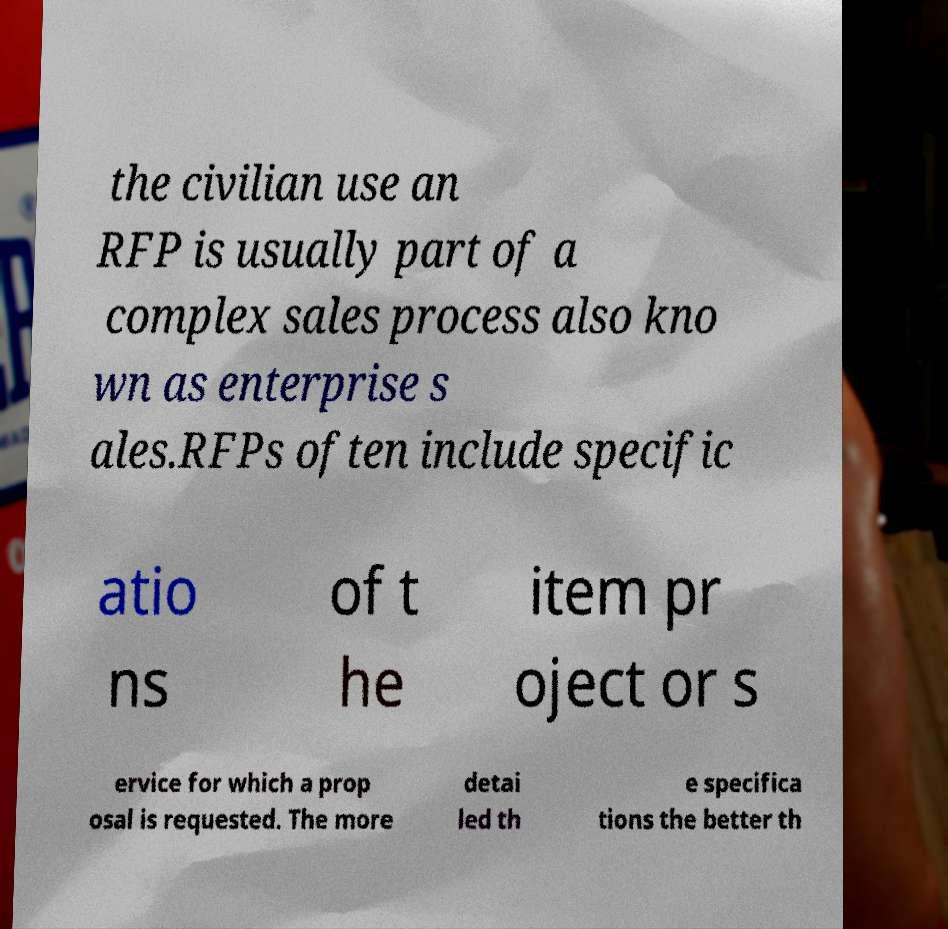Can you read and provide the text displayed in the image?This photo seems to have some interesting text. Can you extract and type it out for me? the civilian use an RFP is usually part of a complex sales process also kno wn as enterprise s ales.RFPs often include specific atio ns of t he item pr oject or s ervice for which a prop osal is requested. The more detai led th e specifica tions the better th 